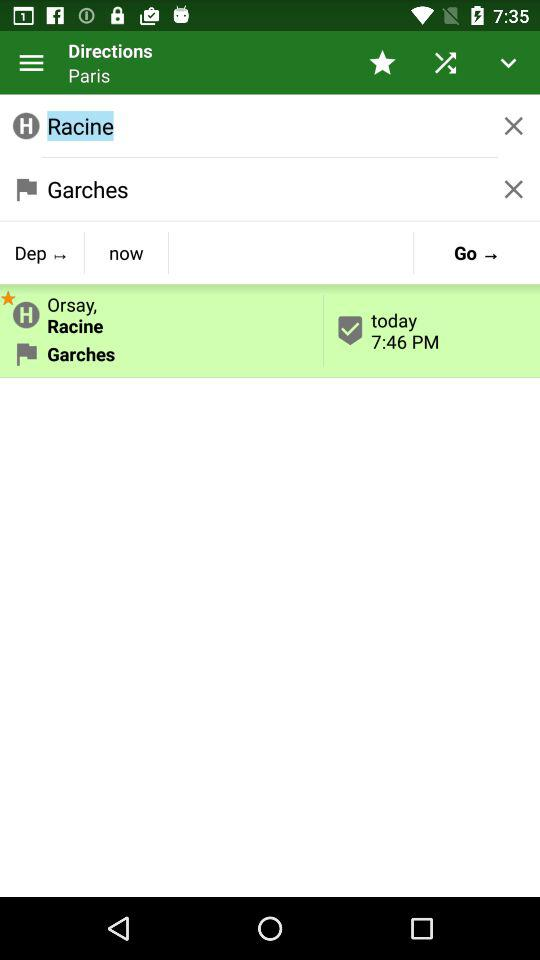What city is mentioned in the "Directions"? The mentioned city is Paris. 